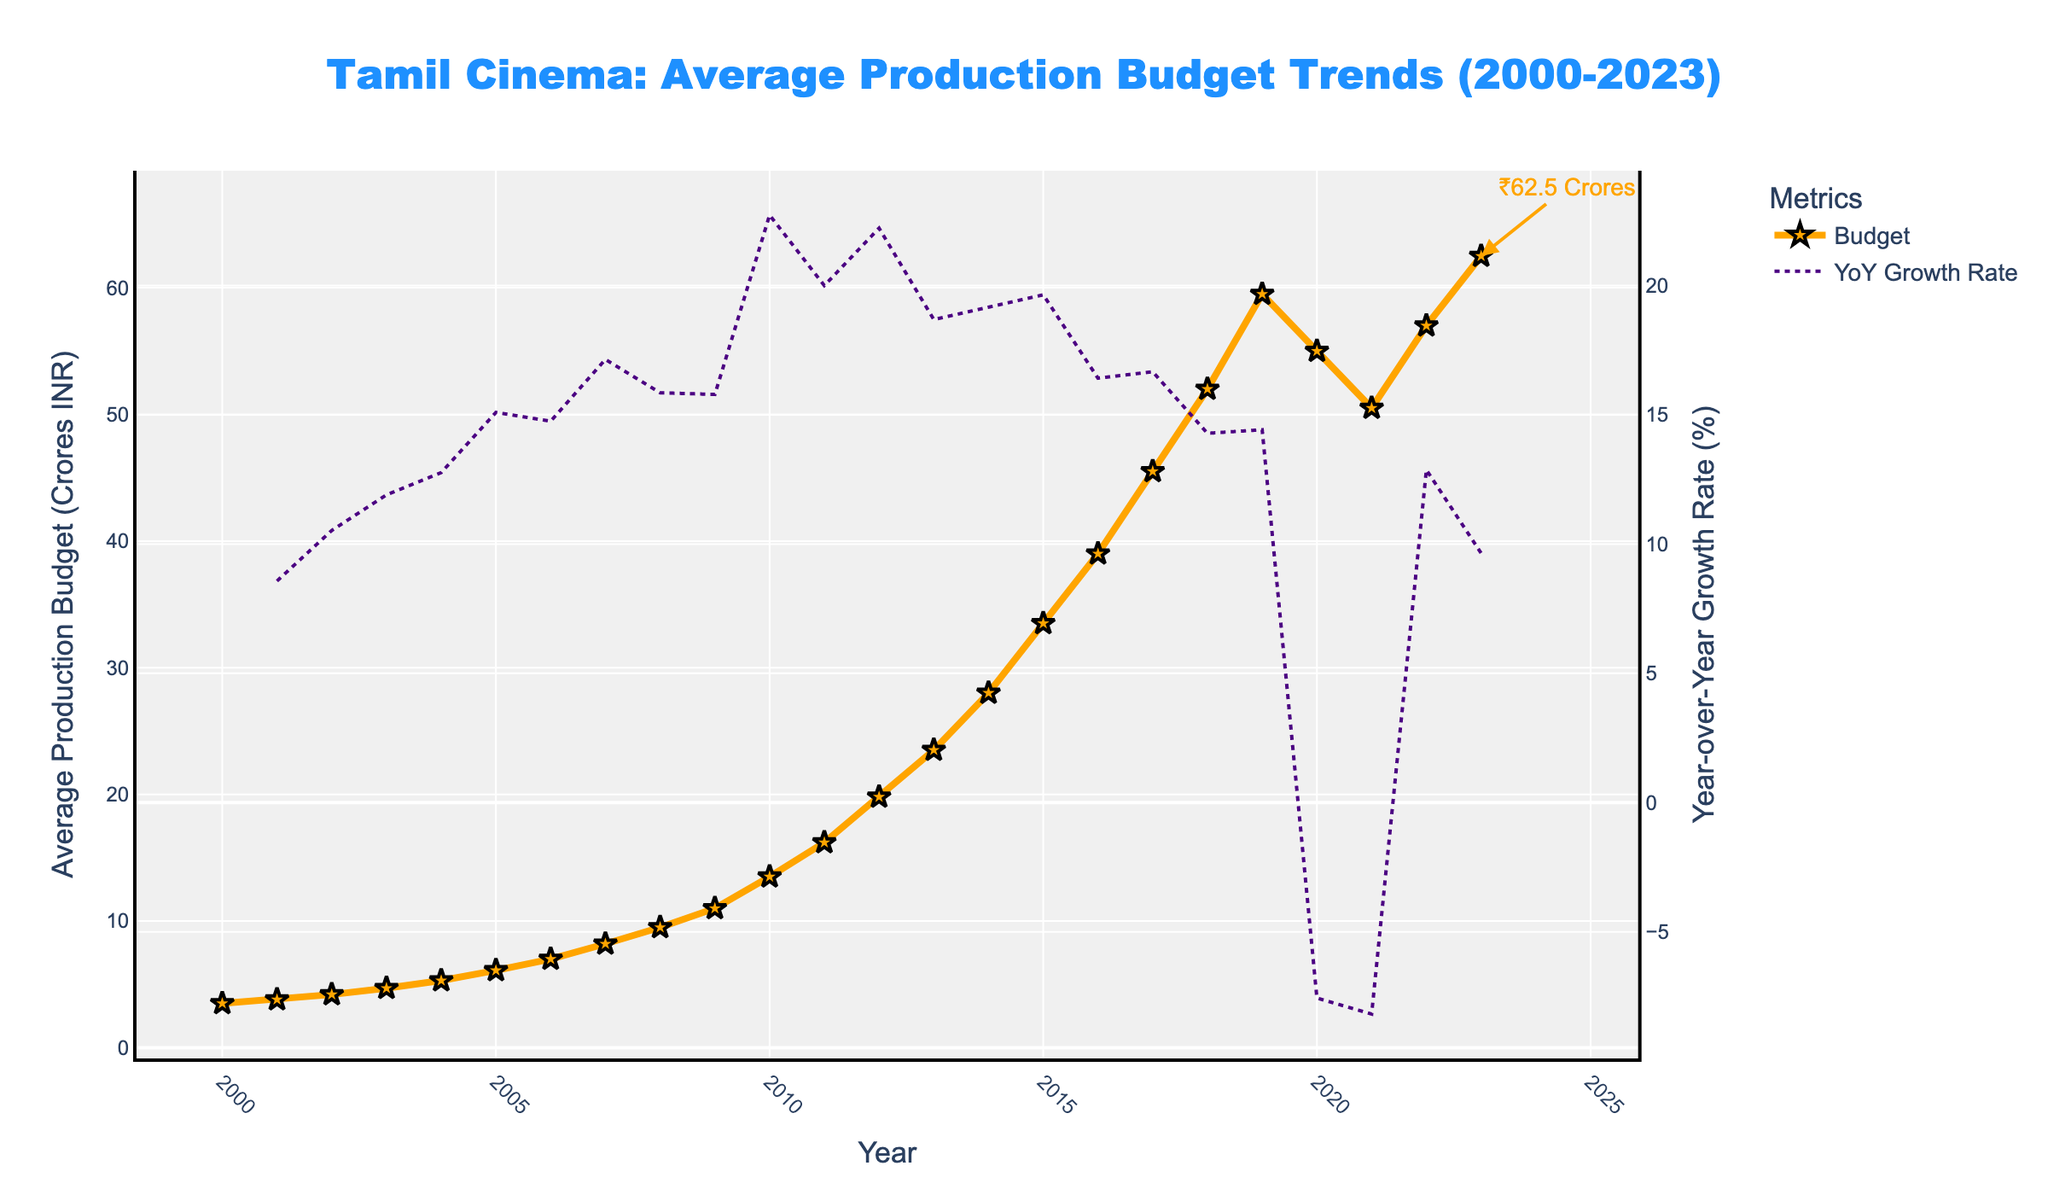What is the average production budget in 2023? According to the plot, the average production budget for 2023 can be found by locating the data point for the year 2023. The annotation highlights that the budget is ₹62.5 Crores.
Answer: ₹62.5 Crores How much did the average production budget increase from 2000 to 2023? To find the increase, subtract the budget in 2000 from the budget in 2023. From the data, the budget in 2000 is ₹3.5 Crores, and in 2023 it is ₹62.5 Crores. Thus, the increase is ₹62.5 Crores - ₹3.5 Crores = ₹59 Crores.
Answer: ₹59 Crores Which year experienced the highest year-over-year growth rate? Review the line representing the YoY growth rate on the secondary y-axis. The peak of the purple dotted line indicates the highest YoY growth, which occurs around 2009.
Answer: 2009 Were there any years when the average production budget decreased? Look at the trend line to identify any declines. Between 2019 and 2020, and 2020 and 2021, there's a noticeable dip indicating a decrease.
Answer: Yes What was the year-over-year growth rate for 2023? Refer to the plot's secondary y-axis, and find the YoY growth rate value for the year 2023. The plot should show a specific point for this year.
Answer: Positive (specific value not provided) In which year did the average production budget exceed ₹50 Crores for the first time? Locate the point where the budget crosses ₹50 Crores on the y-axis. This occurs for the first time in 2018.
Answer: 2018 Compare the average production budgets of 2016 and 2023. Which year had a higher budget, and by how much? Find the values for each year and compare: 2016's budget is ₹39 Crores and 2023’s is ₹62.5 Crores. Subtract to find the difference: ₹62.5 Crores - ₹39 Crores = ₹23.5 Crores. Therefore, 2023 had a higher budget by ₹23.5 Crores.
Answer: 2023, ₹23.5 Crores Describe the trend in the average production budget from 2000 to 2019. From the plot, observe the consistent rise in the budget every year from 2000 to 2019, indicating a steady growth trend without any decreases.
Answer: Steady growth When did the average production budget experience the most significant decline, and what was the decrease? Identify the steepest downward slope in the plot. This occurs from 2019 to 2020. The budget decreased from ₹59.5 Crores to ₹55 Crores, a decrease of ₹4.5 Crores.
Answer: 2019 to 2020, ₹4.5 Crores What is the color used to represent the line for the year-over-year growth rate in the plot? The secondary y-axis representing the YoY growth rate is shown with a purple dotted line.
Answer: Purple 